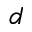<formula> <loc_0><loc_0><loc_500><loc_500>d</formula> 